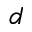<formula> <loc_0><loc_0><loc_500><loc_500>d</formula> 